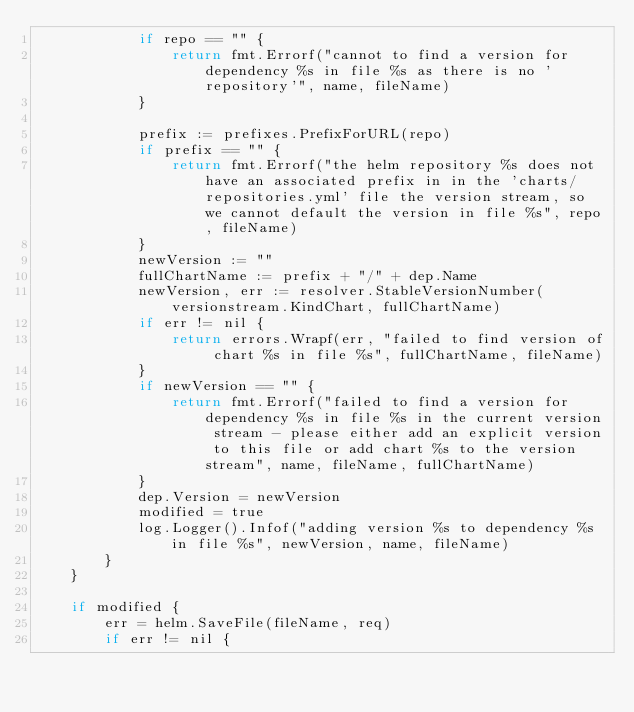Convert code to text. <code><loc_0><loc_0><loc_500><loc_500><_Go_>			if repo == "" {
				return fmt.Errorf("cannot to find a version for dependency %s in file %s as there is no 'repository'", name, fileName)
			}

			prefix := prefixes.PrefixForURL(repo)
			if prefix == "" {
				return fmt.Errorf("the helm repository %s does not have an associated prefix in in the 'charts/repositories.yml' file the version stream, so we cannot default the version in file %s", repo, fileName)
			}
			newVersion := ""
			fullChartName := prefix + "/" + dep.Name
			newVersion, err := resolver.StableVersionNumber(versionstream.KindChart, fullChartName)
			if err != nil {
				return errors.Wrapf(err, "failed to find version of chart %s in file %s", fullChartName, fileName)
			}
			if newVersion == "" {
				return fmt.Errorf("failed to find a version for dependency %s in file %s in the current version stream - please either add an explicit version to this file or add chart %s to the version stream", name, fileName, fullChartName)
			}
			dep.Version = newVersion
			modified = true
			log.Logger().Infof("adding version %s to dependency %s in file %s", newVersion, name, fileName)
		}
	}

	if modified {
		err = helm.SaveFile(fileName, req)
		if err != nil {</code> 